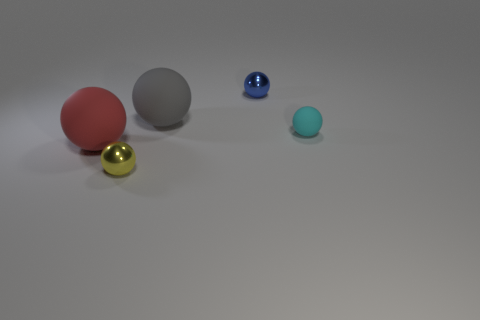Add 3 large cyan matte blocks. How many objects exist? 8 Subtract 1 balls. How many balls are left? 4 Subtract all tiny metal spheres. How many spheres are left? 3 Add 1 large rubber balls. How many large rubber balls are left? 3 Add 5 tiny yellow balls. How many tiny yellow balls exist? 6 Subtract all yellow balls. How many balls are left? 4 Subtract 0 cyan blocks. How many objects are left? 5 Subtract all yellow balls. Subtract all blue cubes. How many balls are left? 4 Subtract all cyan cylinders. How many gray spheres are left? 1 Subtract all cyan metal things. Subtract all small shiny objects. How many objects are left? 3 